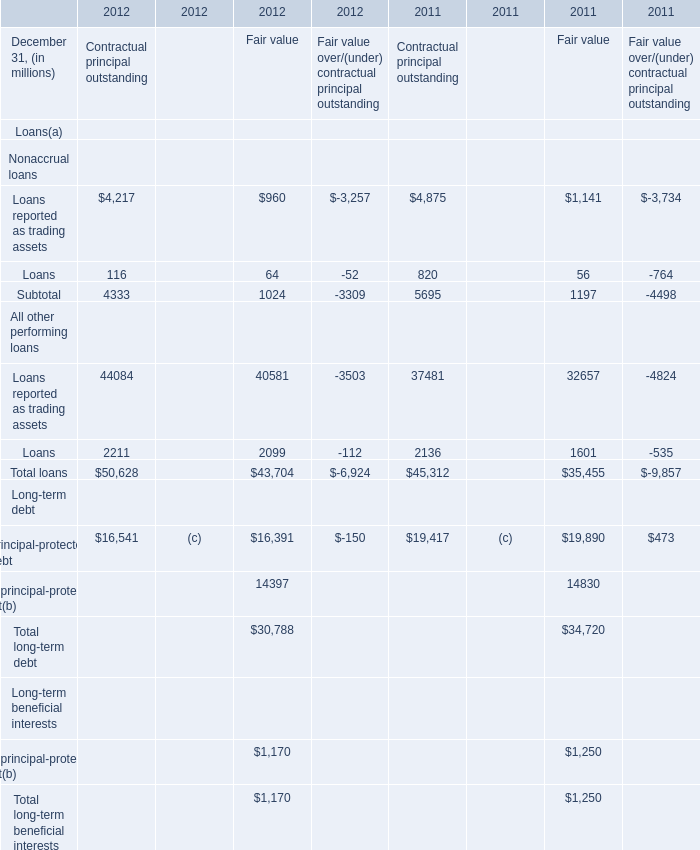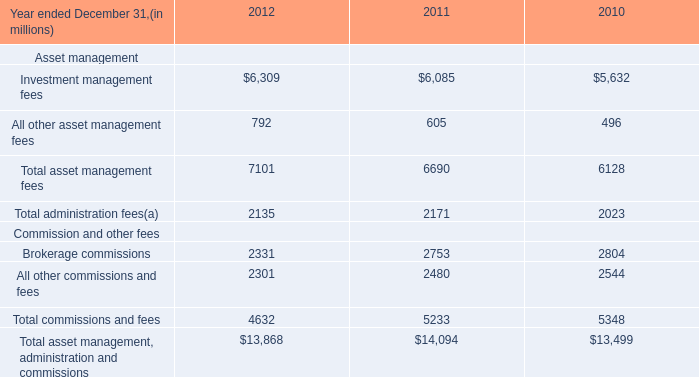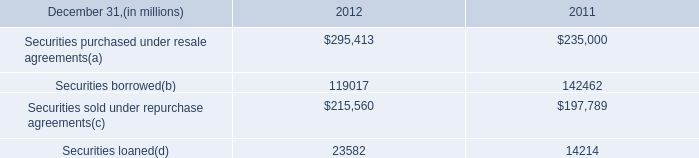What is the proportion of all elements for Fair value that are greater than 10000 to the total amount of elements in 2011? 
Computations: (((32657 + 19890) + 14830) / (((1197 + 35455) + 34720) + 1250))
Answer: 0.92778. 